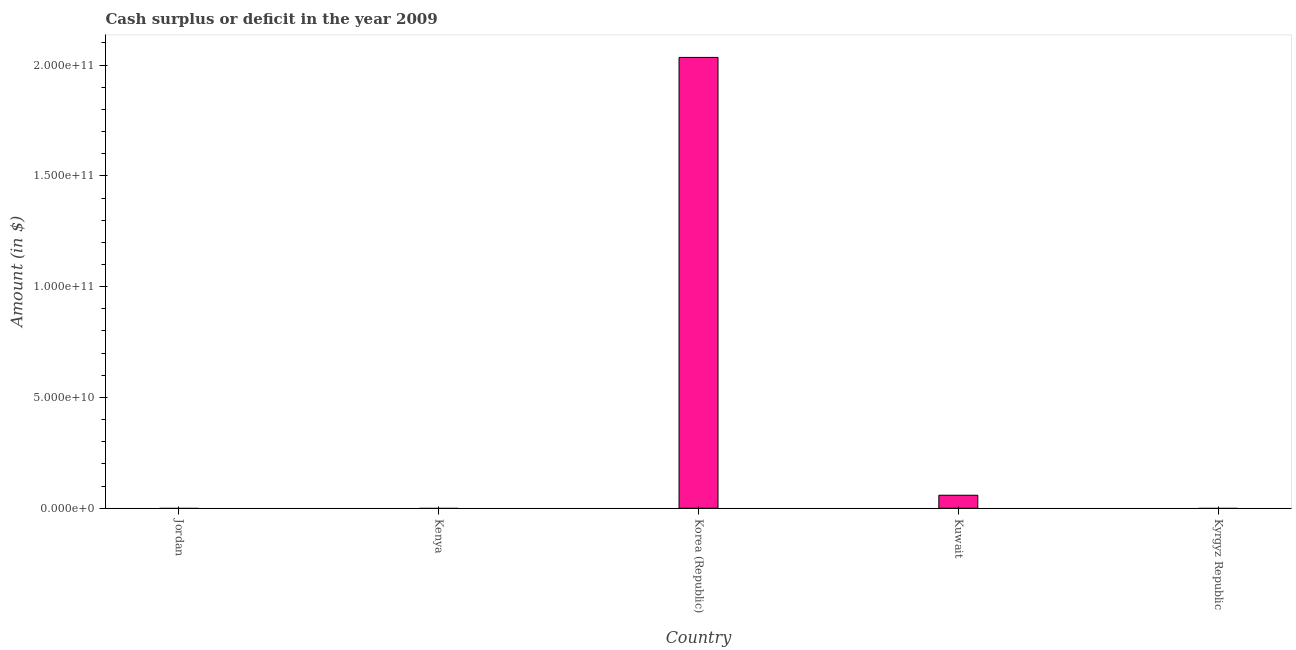What is the title of the graph?
Your response must be concise. Cash surplus or deficit in the year 2009. What is the label or title of the X-axis?
Provide a short and direct response. Country. What is the label or title of the Y-axis?
Provide a succinct answer. Amount (in $). What is the cash surplus or deficit in Korea (Republic)?
Make the answer very short. 2.03e+11. Across all countries, what is the maximum cash surplus or deficit?
Your answer should be compact. 2.03e+11. What is the sum of the cash surplus or deficit?
Offer a terse response. 2.09e+11. What is the difference between the cash surplus or deficit in Korea (Republic) and Kuwait?
Your response must be concise. 1.98e+11. What is the average cash surplus or deficit per country?
Keep it short and to the point. 4.19e+1. What is the median cash surplus or deficit?
Ensure brevity in your answer.  0. Is the cash surplus or deficit in Korea (Republic) less than that in Kuwait?
Offer a very short reply. No. Is the difference between the cash surplus or deficit in Korea (Republic) and Kuwait greater than the difference between any two countries?
Keep it short and to the point. No. What is the difference between the highest and the lowest cash surplus or deficit?
Your answer should be very brief. 2.03e+11. In how many countries, is the cash surplus or deficit greater than the average cash surplus or deficit taken over all countries?
Your response must be concise. 1. Are all the bars in the graph horizontal?
Your answer should be compact. No. How many countries are there in the graph?
Make the answer very short. 5. What is the difference between two consecutive major ticks on the Y-axis?
Keep it short and to the point. 5.00e+1. Are the values on the major ticks of Y-axis written in scientific E-notation?
Provide a succinct answer. Yes. What is the Amount (in $) in Korea (Republic)?
Provide a short and direct response. 2.03e+11. What is the Amount (in $) of Kuwait?
Your response must be concise. 5.88e+09. What is the difference between the Amount (in $) in Korea (Republic) and Kuwait?
Ensure brevity in your answer.  1.98e+11. What is the ratio of the Amount (in $) in Korea (Republic) to that in Kuwait?
Make the answer very short. 34.59. 